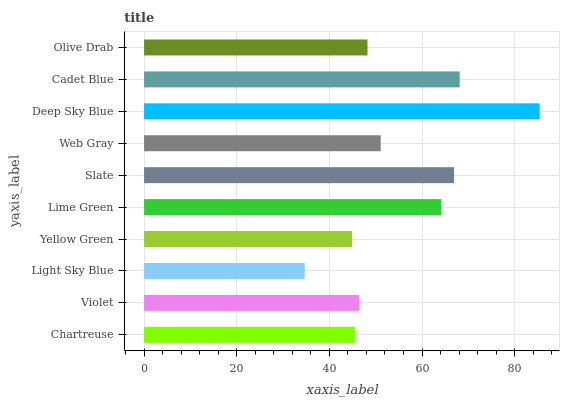Is Light Sky Blue the minimum?
Answer yes or no. Yes. Is Deep Sky Blue the maximum?
Answer yes or no. Yes. Is Violet the minimum?
Answer yes or no. No. Is Violet the maximum?
Answer yes or no. No. Is Violet greater than Chartreuse?
Answer yes or no. Yes. Is Chartreuse less than Violet?
Answer yes or no. Yes. Is Chartreuse greater than Violet?
Answer yes or no. No. Is Violet less than Chartreuse?
Answer yes or no. No. Is Web Gray the high median?
Answer yes or no. Yes. Is Olive Drab the low median?
Answer yes or no. Yes. Is Violet the high median?
Answer yes or no. No. Is Yellow Green the low median?
Answer yes or no. No. 